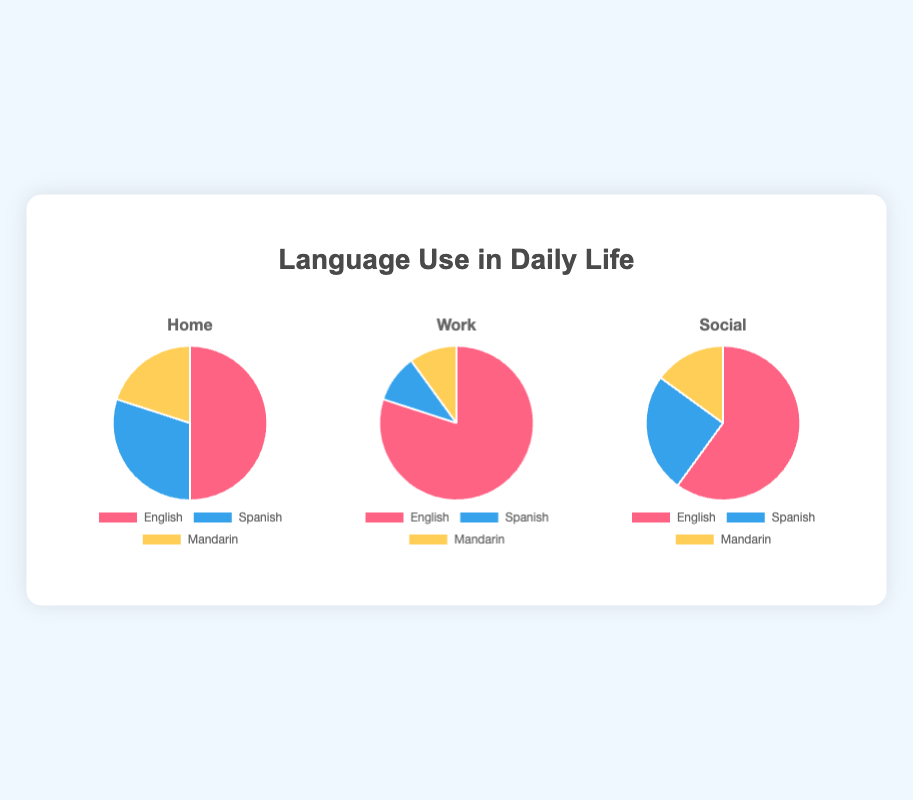Which language is most used at home? By looking at the pie chart for 'Home', the largest section (half of the chart) is for English.
Answer: English Which two languages have the same usage percentage at work? By examining the pie chart for 'Work', the sections for Spanish and Mandarin are equal in size, each representing 10%.
Answer: Spanish, Mandarin How much more is English spoken at work compared to home? In the 'Work' pie chart, English is used 80%. At home, it is used 50%. The difference is 80% - 50% = 30%.
Answer: 30% Which language is most balanced in its usage across all three contexts? Looking at the three contexts (Home, Work, Social), Mandarin has the most similar usage, with 20% at home, 10% at work, and 15% socially, while English and Spanish have larger variances.
Answer: Mandarin Among home, work, and social contexts, where is Spanish usage the lowest? In the 'Work' pie chart, Spanish usage is the smallest slice at 10%, compared to 30% at home and 25% socially.
Answer: Work Calculate the total percentage of languages other than English used at home. At home, Spanish is 30% and Mandarin is 20%. Adding these together: 30% + 20% = 50%.
Answer: 50% What percentage of total language use at home does Mandarin represent? Mandarin is 20% of the total 100% usage at home.
Answer: 20% Across all contexts, which has higher usage of Spanish: Social or Home? In home, Spanish usage is 30%. In the social context, it is 25%. So 30% > 25%.
Answer: Home By how much does English usage decrease from work to social context? English usage at work is 80%, and in the social context, it is 60%. The decrease is 80% - 60% = 20%.
Answer: 20% What is the combined percentage of Mandarin usage in both social and work contexts? Mandarin usage is 15% in the social context and 10% at work. Combining these, 15% + 10% = 25%.
Answer: 25% 